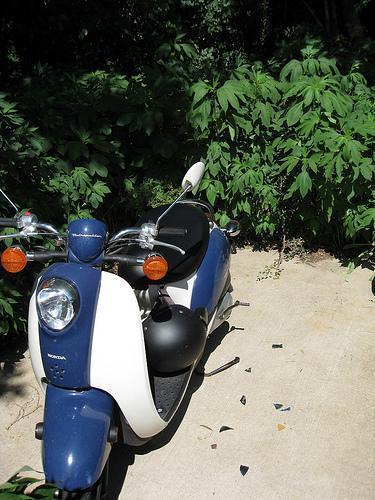How many scooters are in the picture?
Give a very brief answer. 1. How many reflectors are on the front of the scooter?
Give a very brief answer. 2. 